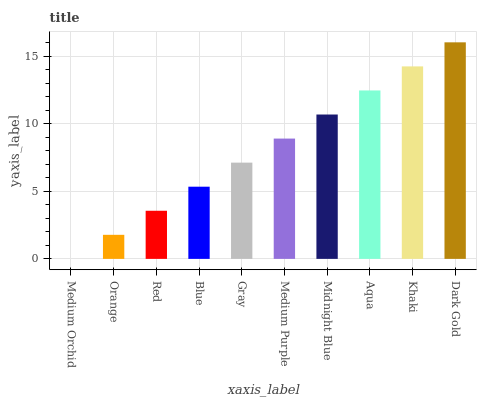Is Medium Orchid the minimum?
Answer yes or no. Yes. Is Dark Gold the maximum?
Answer yes or no. Yes. Is Orange the minimum?
Answer yes or no. No. Is Orange the maximum?
Answer yes or no. No. Is Orange greater than Medium Orchid?
Answer yes or no. Yes. Is Medium Orchid less than Orange?
Answer yes or no. Yes. Is Medium Orchid greater than Orange?
Answer yes or no. No. Is Orange less than Medium Orchid?
Answer yes or no. No. Is Medium Purple the high median?
Answer yes or no. Yes. Is Gray the low median?
Answer yes or no. Yes. Is Midnight Blue the high median?
Answer yes or no. No. Is Medium Purple the low median?
Answer yes or no. No. 